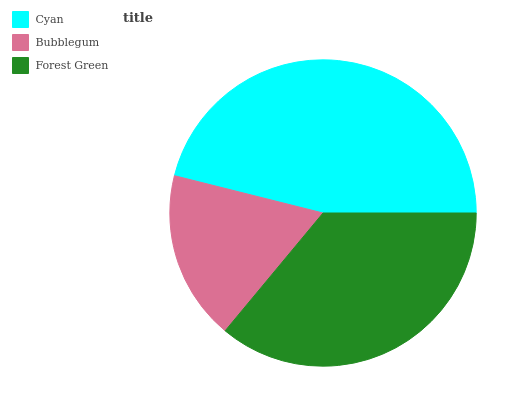Is Bubblegum the minimum?
Answer yes or no. Yes. Is Cyan the maximum?
Answer yes or no. Yes. Is Forest Green the minimum?
Answer yes or no. No. Is Forest Green the maximum?
Answer yes or no. No. Is Forest Green greater than Bubblegum?
Answer yes or no. Yes. Is Bubblegum less than Forest Green?
Answer yes or no. Yes. Is Bubblegum greater than Forest Green?
Answer yes or no. No. Is Forest Green less than Bubblegum?
Answer yes or no. No. Is Forest Green the high median?
Answer yes or no. Yes. Is Forest Green the low median?
Answer yes or no. Yes. Is Cyan the high median?
Answer yes or no. No. Is Bubblegum the low median?
Answer yes or no. No. 